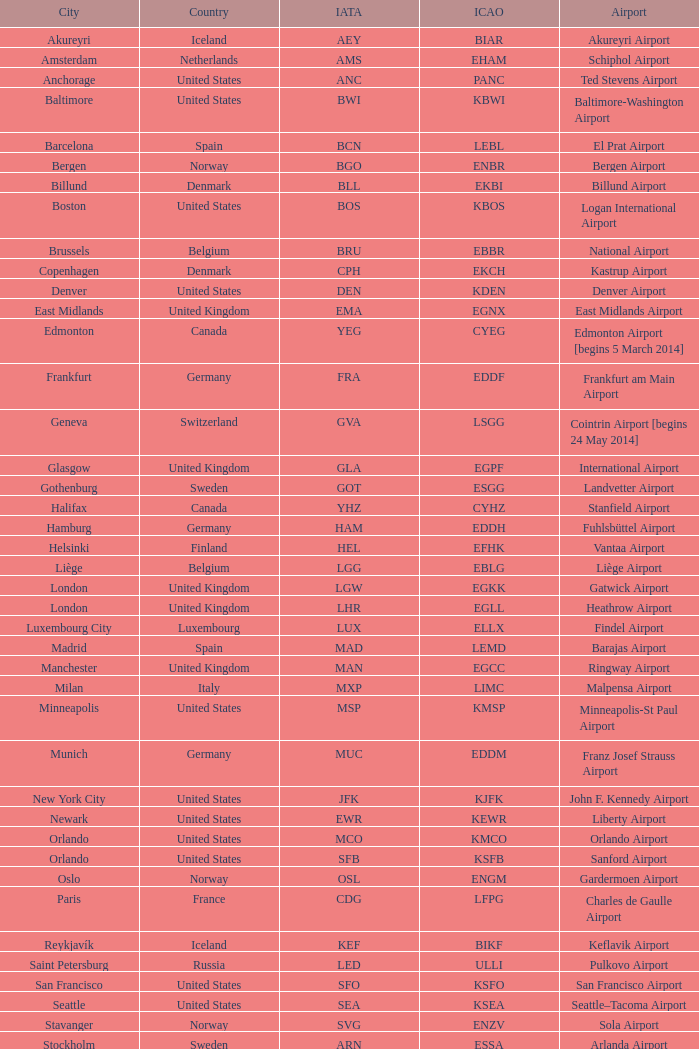What is the City with an IATA of MUC? Munich. 